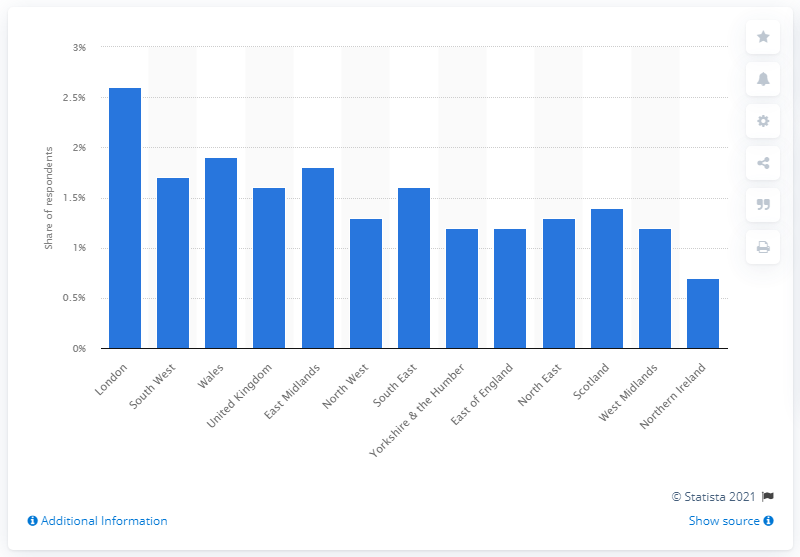Point out several critical features in this image. The prevalence of homosexuality in Northern Ireland is 0.7%. In 2019, approximately 1.6% of the population of the UK identified themselves as being homosexual. According to recent estimates, the lowest percentage of homosexuals in Northern Ireland is 0.7%. According to a survey conducted in 2019, approximately 1.6% of the population of the United Kingdom identified themselves as being homosexual. 